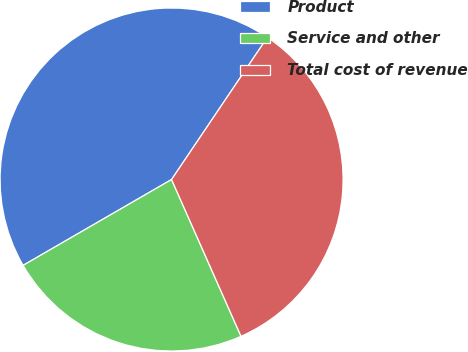Convert chart. <chart><loc_0><loc_0><loc_500><loc_500><pie_chart><fcel>Product<fcel>Service and other<fcel>Total cost of revenue<nl><fcel>42.78%<fcel>23.29%<fcel>33.92%<nl></chart> 